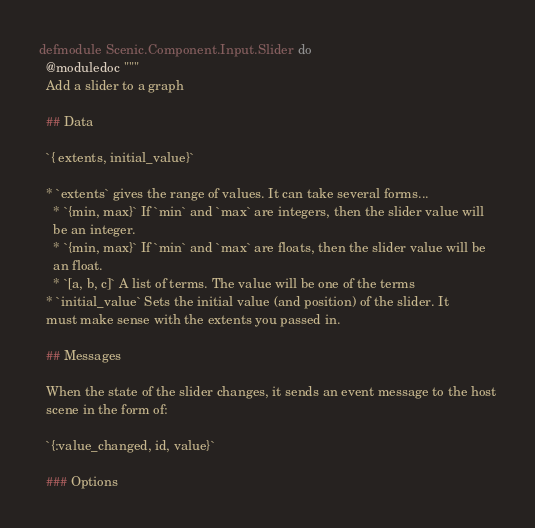Convert code to text. <code><loc_0><loc_0><loc_500><loc_500><_Elixir_>defmodule Scenic.Component.Input.Slider do
  @moduledoc """
  Add a slider to a graph

  ## Data

  `{ extents, initial_value}`

  * `extents` gives the range of values. It can take several forms...
    * `{min, max}` If `min` and `max` are integers, then the slider value will
    be an integer.
    * `{min, max}` If `min` and `max` are floats, then the slider value will be
    an float.
    * `[a, b, c]` A list of terms. The value will be one of the terms
  * `initial_value` Sets the initial value (and position) of the slider. It
  must make sense with the extents you passed in.

  ## Messages

  When the state of the slider changes, it sends an event message to the host
  scene in the form of:

  `{:value_changed, id, value}`

  ### Options
</code> 